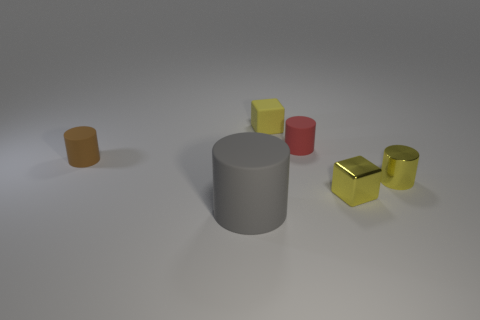Are there any other things that have the same size as the gray object?
Your answer should be very brief. No. What is the color of the metallic thing that is the same size as the yellow cylinder?
Make the answer very short. Yellow. There is a matte cylinder that is to the right of the large gray rubber cylinder; does it have the same size as the yellow cube that is on the right side of the yellow matte thing?
Keep it short and to the point. Yes. What size is the block on the right side of the red object that is behind the object in front of the metal cube?
Provide a succinct answer. Small. The tiny yellow object behind the tiny cylinder that is left of the gray thing is what shape?
Give a very brief answer. Cube. There is a tiny block behind the metal block; is it the same color as the small metal cylinder?
Provide a succinct answer. Yes. What color is the tiny object that is behind the metallic cube and on the right side of the red rubber cylinder?
Your answer should be very brief. Yellow. Are there any red things made of the same material as the large gray cylinder?
Offer a terse response. Yes. The red thing is what size?
Give a very brief answer. Small. How big is the brown matte cylinder to the left of the yellow block that is behind the tiny red rubber cylinder?
Keep it short and to the point. Small. 